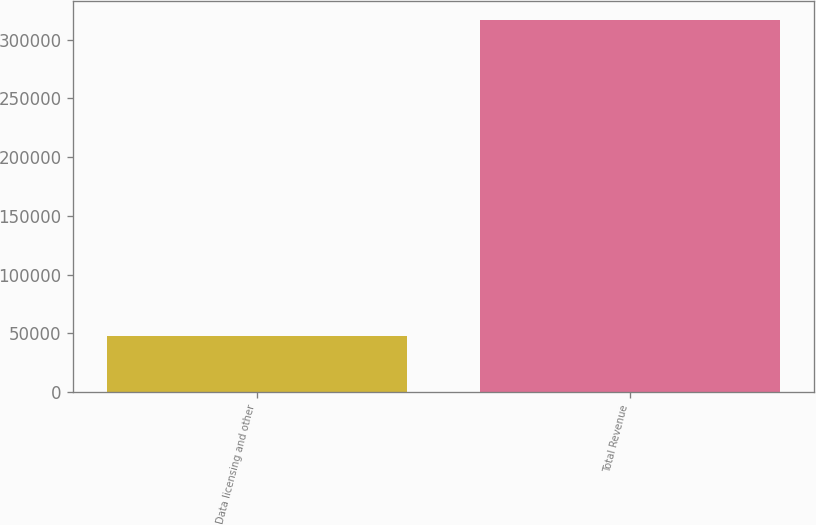<chart> <loc_0><loc_0><loc_500><loc_500><bar_chart><fcel>Data licensing and other<fcel>Total Revenue<nl><fcel>47512<fcel>316933<nl></chart> 